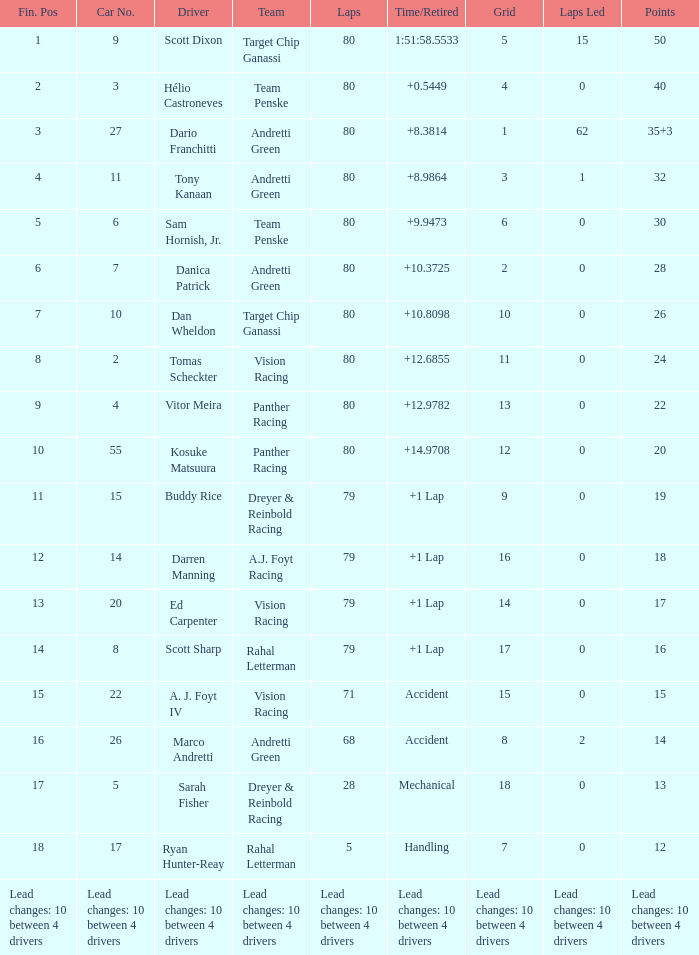What grid has 24 points? 11.0. 